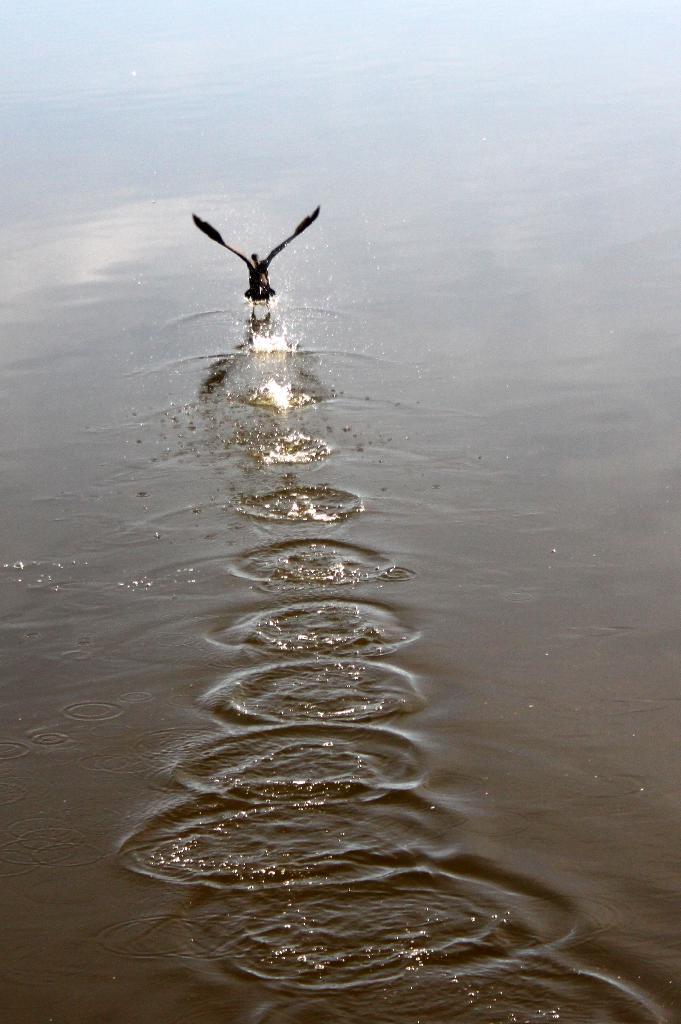Describe this image in one or two sentences. In this image there is a bird flying over the water. Background there is water having ripples in it. 